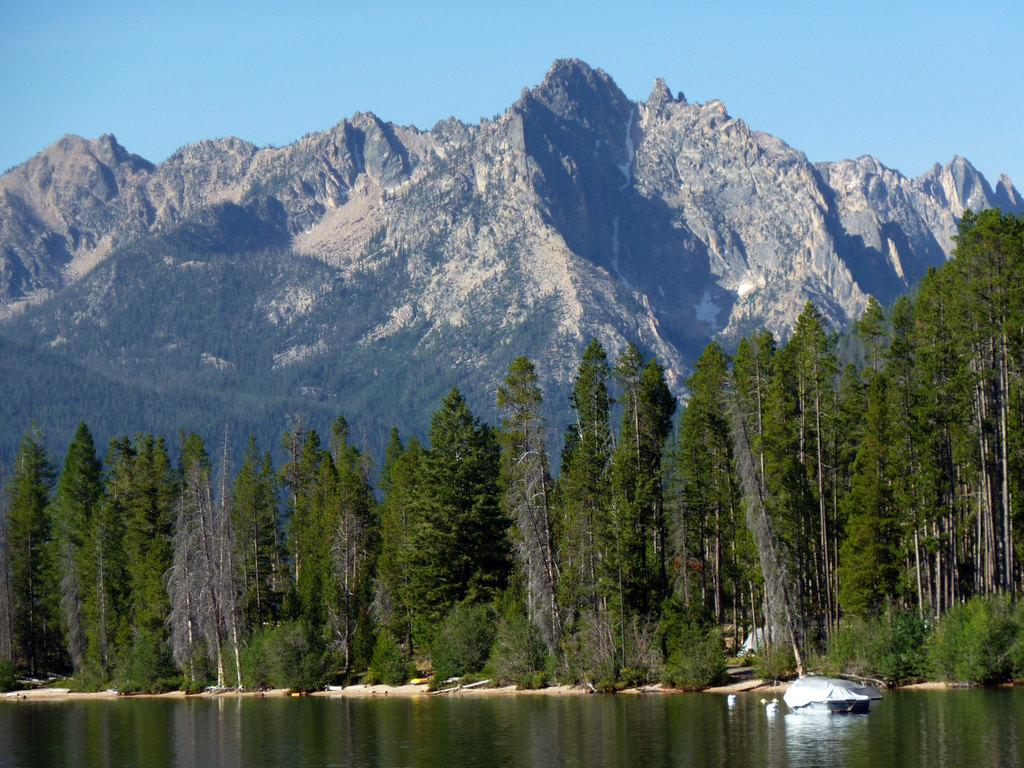What is located in the water in the image? There is an object in the water in the image. What type of vegetation can be seen on the land? There are trees on the land in the image. What geographical feature is visible in the background? There is a hill visible in the background of the image. What is visible at the top of the image? The sky is visible at the top of the image. What type of potato is being used as a vacation spot in the image? There is no potato or vacation spot present in the image. What is the position of the object in the water in relation to the trees on the land? The position of the object in the water in relation to the trees on the land cannot be determined from the image alone. 